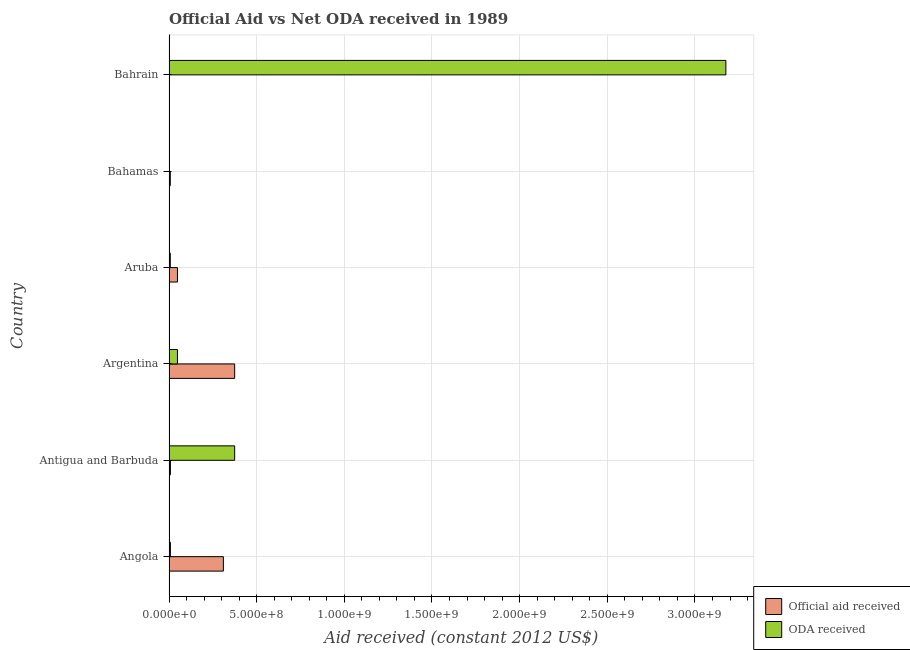Are the number of bars per tick equal to the number of legend labels?
Your answer should be compact. No. How many bars are there on the 6th tick from the top?
Your answer should be very brief. 2. How many bars are there on the 4th tick from the bottom?
Provide a short and direct response. 2. What is the label of the 6th group of bars from the top?
Ensure brevity in your answer.  Angola. What is the oda received in Angola?
Provide a succinct answer. 8.02e+06. Across all countries, what is the maximum oda received?
Ensure brevity in your answer.  3.18e+09. In which country was the oda received maximum?
Offer a terse response. Bahrain. What is the total oda received in the graph?
Provide a succinct answer. 3.61e+09. What is the difference between the official aid received in Angola and that in Antigua and Barbuda?
Your answer should be very brief. 3.02e+08. What is the difference between the oda received in Argentina and the official aid received in Bahamas?
Your answer should be compact. 4.10e+07. What is the average official aid received per country?
Give a very brief answer. 1.25e+08. What is the difference between the oda received and official aid received in Argentina?
Provide a short and direct response. -3.26e+08. In how many countries, is the oda received greater than 1400000000 US$?
Give a very brief answer. 1. What is the ratio of the official aid received in Angola to that in Argentina?
Offer a very short reply. 0.83. Is the oda received in Antigua and Barbuda less than that in Argentina?
Your answer should be very brief. No. What is the difference between the highest and the second highest official aid received?
Your answer should be very brief. 6.43e+07. What is the difference between the highest and the lowest oda received?
Provide a short and direct response. 3.18e+09. In how many countries, is the oda received greater than the average oda received taken over all countries?
Provide a short and direct response. 1. How many countries are there in the graph?
Your answer should be compact. 6. What is the difference between two consecutive major ticks on the X-axis?
Keep it short and to the point. 5.00e+08. Are the values on the major ticks of X-axis written in scientific E-notation?
Keep it short and to the point. Yes. Does the graph contain any zero values?
Your answer should be very brief. Yes. Where does the legend appear in the graph?
Give a very brief answer. Bottom right. How many legend labels are there?
Offer a very short reply. 2. What is the title of the graph?
Give a very brief answer. Official Aid vs Net ODA received in 1989 . Does "Female labor force" appear as one of the legend labels in the graph?
Make the answer very short. No. What is the label or title of the X-axis?
Give a very brief answer. Aid received (constant 2012 US$). What is the label or title of the Y-axis?
Your answer should be very brief. Country. What is the Aid received (constant 2012 US$) of Official aid received in Angola?
Make the answer very short. 3.10e+08. What is the Aid received (constant 2012 US$) of ODA received in Angola?
Your response must be concise. 8.02e+06. What is the Aid received (constant 2012 US$) of Official aid received in Antigua and Barbuda?
Your answer should be very brief. 8.02e+06. What is the Aid received (constant 2012 US$) in ODA received in Antigua and Barbuda?
Make the answer very short. 3.74e+08. What is the Aid received (constant 2012 US$) of Official aid received in Argentina?
Keep it short and to the point. 3.74e+08. What is the Aid received (constant 2012 US$) of ODA received in Argentina?
Make the answer very short. 4.83e+07. What is the Aid received (constant 2012 US$) of Official aid received in Aruba?
Provide a succinct answer. 4.83e+07. What is the Aid received (constant 2012 US$) in ODA received in Aruba?
Keep it short and to the point. 7.36e+06. What is the Aid received (constant 2012 US$) of Official aid received in Bahamas?
Provide a short and direct response. 7.36e+06. What is the Aid received (constant 2012 US$) of ODA received in Bahamas?
Your answer should be compact. 0. What is the Aid received (constant 2012 US$) of ODA received in Bahrain?
Offer a terse response. 3.18e+09. Across all countries, what is the maximum Aid received (constant 2012 US$) of Official aid received?
Offer a very short reply. 3.74e+08. Across all countries, what is the maximum Aid received (constant 2012 US$) in ODA received?
Offer a terse response. 3.18e+09. Across all countries, what is the minimum Aid received (constant 2012 US$) in Official aid received?
Provide a short and direct response. 0. What is the total Aid received (constant 2012 US$) of Official aid received in the graph?
Your response must be concise. 7.48e+08. What is the total Aid received (constant 2012 US$) in ODA received in the graph?
Make the answer very short. 3.61e+09. What is the difference between the Aid received (constant 2012 US$) in Official aid received in Angola and that in Antigua and Barbuda?
Give a very brief answer. 3.02e+08. What is the difference between the Aid received (constant 2012 US$) of ODA received in Angola and that in Antigua and Barbuda?
Offer a very short reply. -3.66e+08. What is the difference between the Aid received (constant 2012 US$) of Official aid received in Angola and that in Argentina?
Provide a short and direct response. -6.43e+07. What is the difference between the Aid received (constant 2012 US$) in ODA received in Angola and that in Argentina?
Keep it short and to the point. -4.03e+07. What is the difference between the Aid received (constant 2012 US$) in Official aid received in Angola and that in Aruba?
Ensure brevity in your answer.  2.62e+08. What is the difference between the Aid received (constant 2012 US$) in Official aid received in Angola and that in Bahamas?
Your answer should be very brief. 3.03e+08. What is the difference between the Aid received (constant 2012 US$) of ODA received in Angola and that in Bahrain?
Make the answer very short. -3.17e+09. What is the difference between the Aid received (constant 2012 US$) in Official aid received in Antigua and Barbuda and that in Argentina?
Your answer should be compact. -3.66e+08. What is the difference between the Aid received (constant 2012 US$) in ODA received in Antigua and Barbuda and that in Argentina?
Make the answer very short. 3.26e+08. What is the difference between the Aid received (constant 2012 US$) in Official aid received in Antigua and Barbuda and that in Aruba?
Offer a terse response. -4.03e+07. What is the difference between the Aid received (constant 2012 US$) of ODA received in Antigua and Barbuda and that in Aruba?
Offer a terse response. 3.67e+08. What is the difference between the Aid received (constant 2012 US$) in ODA received in Antigua and Barbuda and that in Bahrain?
Your answer should be very brief. -2.80e+09. What is the difference between the Aid received (constant 2012 US$) in Official aid received in Argentina and that in Aruba?
Keep it short and to the point. 3.26e+08. What is the difference between the Aid received (constant 2012 US$) of ODA received in Argentina and that in Aruba?
Make the answer very short. 4.10e+07. What is the difference between the Aid received (constant 2012 US$) of Official aid received in Argentina and that in Bahamas?
Your answer should be very brief. 3.67e+08. What is the difference between the Aid received (constant 2012 US$) in ODA received in Argentina and that in Bahrain?
Keep it short and to the point. -3.13e+09. What is the difference between the Aid received (constant 2012 US$) of Official aid received in Aruba and that in Bahamas?
Provide a succinct answer. 4.10e+07. What is the difference between the Aid received (constant 2012 US$) in ODA received in Aruba and that in Bahrain?
Keep it short and to the point. -3.17e+09. What is the difference between the Aid received (constant 2012 US$) of Official aid received in Angola and the Aid received (constant 2012 US$) of ODA received in Antigua and Barbuda?
Offer a very short reply. -6.43e+07. What is the difference between the Aid received (constant 2012 US$) in Official aid received in Angola and the Aid received (constant 2012 US$) in ODA received in Argentina?
Offer a very short reply. 2.62e+08. What is the difference between the Aid received (constant 2012 US$) in Official aid received in Angola and the Aid received (constant 2012 US$) in ODA received in Aruba?
Give a very brief answer. 3.03e+08. What is the difference between the Aid received (constant 2012 US$) of Official aid received in Angola and the Aid received (constant 2012 US$) of ODA received in Bahrain?
Provide a succinct answer. -2.87e+09. What is the difference between the Aid received (constant 2012 US$) of Official aid received in Antigua and Barbuda and the Aid received (constant 2012 US$) of ODA received in Argentina?
Your response must be concise. -4.03e+07. What is the difference between the Aid received (constant 2012 US$) of Official aid received in Antigua and Barbuda and the Aid received (constant 2012 US$) of ODA received in Aruba?
Offer a very short reply. 6.60e+05. What is the difference between the Aid received (constant 2012 US$) in Official aid received in Antigua and Barbuda and the Aid received (constant 2012 US$) in ODA received in Bahrain?
Your answer should be compact. -3.17e+09. What is the difference between the Aid received (constant 2012 US$) of Official aid received in Argentina and the Aid received (constant 2012 US$) of ODA received in Aruba?
Provide a short and direct response. 3.67e+08. What is the difference between the Aid received (constant 2012 US$) of Official aid received in Argentina and the Aid received (constant 2012 US$) of ODA received in Bahrain?
Provide a succinct answer. -2.80e+09. What is the difference between the Aid received (constant 2012 US$) in Official aid received in Aruba and the Aid received (constant 2012 US$) in ODA received in Bahrain?
Ensure brevity in your answer.  -3.13e+09. What is the difference between the Aid received (constant 2012 US$) of Official aid received in Bahamas and the Aid received (constant 2012 US$) of ODA received in Bahrain?
Your answer should be very brief. -3.17e+09. What is the average Aid received (constant 2012 US$) in Official aid received per country?
Provide a short and direct response. 1.25e+08. What is the average Aid received (constant 2012 US$) of ODA received per country?
Provide a succinct answer. 6.02e+08. What is the difference between the Aid received (constant 2012 US$) of Official aid received and Aid received (constant 2012 US$) of ODA received in Angola?
Offer a terse response. 3.02e+08. What is the difference between the Aid received (constant 2012 US$) in Official aid received and Aid received (constant 2012 US$) in ODA received in Antigua and Barbuda?
Provide a short and direct response. -3.66e+08. What is the difference between the Aid received (constant 2012 US$) of Official aid received and Aid received (constant 2012 US$) of ODA received in Argentina?
Make the answer very short. 3.26e+08. What is the difference between the Aid received (constant 2012 US$) of Official aid received and Aid received (constant 2012 US$) of ODA received in Aruba?
Offer a terse response. 4.10e+07. What is the ratio of the Aid received (constant 2012 US$) of Official aid received in Angola to that in Antigua and Barbuda?
Offer a terse response. 38.67. What is the ratio of the Aid received (constant 2012 US$) of ODA received in Angola to that in Antigua and Barbuda?
Ensure brevity in your answer.  0.02. What is the ratio of the Aid received (constant 2012 US$) in Official aid received in Angola to that in Argentina?
Your answer should be compact. 0.83. What is the ratio of the Aid received (constant 2012 US$) in ODA received in Angola to that in Argentina?
Offer a very short reply. 0.17. What is the ratio of the Aid received (constant 2012 US$) of Official aid received in Angola to that in Aruba?
Your answer should be compact. 6.42. What is the ratio of the Aid received (constant 2012 US$) of ODA received in Angola to that in Aruba?
Give a very brief answer. 1.09. What is the ratio of the Aid received (constant 2012 US$) in Official aid received in Angola to that in Bahamas?
Give a very brief answer. 42.14. What is the ratio of the Aid received (constant 2012 US$) in ODA received in Angola to that in Bahrain?
Your answer should be very brief. 0. What is the ratio of the Aid received (constant 2012 US$) in Official aid received in Antigua and Barbuda to that in Argentina?
Ensure brevity in your answer.  0.02. What is the ratio of the Aid received (constant 2012 US$) in ODA received in Antigua and Barbuda to that in Argentina?
Your response must be concise. 7.75. What is the ratio of the Aid received (constant 2012 US$) in Official aid received in Antigua and Barbuda to that in Aruba?
Make the answer very short. 0.17. What is the ratio of the Aid received (constant 2012 US$) of ODA received in Antigua and Barbuda to that in Aruba?
Your answer should be compact. 50.88. What is the ratio of the Aid received (constant 2012 US$) in Official aid received in Antigua and Barbuda to that in Bahamas?
Your response must be concise. 1.09. What is the ratio of the Aid received (constant 2012 US$) in ODA received in Antigua and Barbuda to that in Bahrain?
Offer a very short reply. 0.12. What is the ratio of the Aid received (constant 2012 US$) of Official aid received in Argentina to that in Aruba?
Your answer should be compact. 7.75. What is the ratio of the Aid received (constant 2012 US$) of ODA received in Argentina to that in Aruba?
Provide a short and direct response. 6.56. What is the ratio of the Aid received (constant 2012 US$) in Official aid received in Argentina to that in Bahamas?
Your response must be concise. 50.88. What is the ratio of the Aid received (constant 2012 US$) of ODA received in Argentina to that in Bahrain?
Offer a very short reply. 0.02. What is the ratio of the Aid received (constant 2012 US$) of Official aid received in Aruba to that in Bahamas?
Your answer should be very brief. 6.56. What is the ratio of the Aid received (constant 2012 US$) of ODA received in Aruba to that in Bahrain?
Make the answer very short. 0. What is the difference between the highest and the second highest Aid received (constant 2012 US$) in Official aid received?
Give a very brief answer. 6.43e+07. What is the difference between the highest and the second highest Aid received (constant 2012 US$) of ODA received?
Offer a very short reply. 2.80e+09. What is the difference between the highest and the lowest Aid received (constant 2012 US$) of Official aid received?
Keep it short and to the point. 3.74e+08. What is the difference between the highest and the lowest Aid received (constant 2012 US$) of ODA received?
Give a very brief answer. 3.18e+09. 